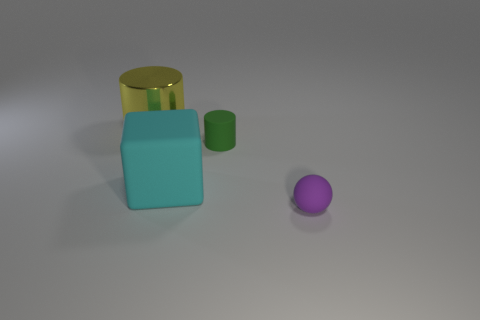What number of other objects are there of the same shape as the big cyan thing?
Offer a very short reply. 0. What shape is the tiny rubber object to the left of the purple thing?
Offer a very short reply. Cylinder. Do the yellow shiny object and the matte object behind the cyan rubber thing have the same shape?
Your answer should be very brief. Yes. How big is the thing that is right of the large cyan matte block and in front of the tiny green rubber cylinder?
Offer a terse response. Small. There is a thing that is on the right side of the large cyan matte thing and behind the large matte block; what color is it?
Provide a succinct answer. Green. Is there anything else that has the same material as the big cylinder?
Provide a succinct answer. No. Is the number of tiny green cylinders in front of the purple sphere less than the number of objects that are on the left side of the green rubber object?
Your answer should be compact. Yes. The large yellow thing has what shape?
Offer a very short reply. Cylinder. What color is the small sphere that is made of the same material as the large cyan object?
Give a very brief answer. Purple. Is the number of tiny green cubes greater than the number of matte blocks?
Your answer should be compact. No. 